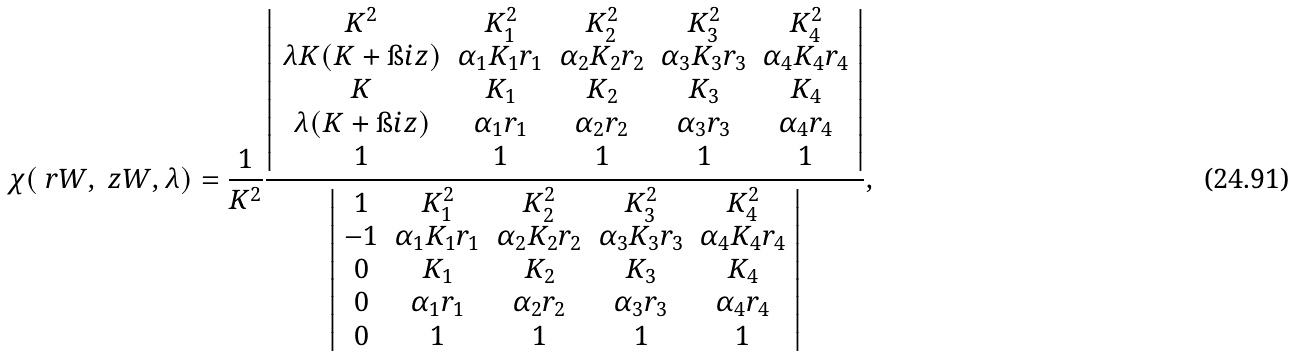<formula> <loc_0><loc_0><loc_500><loc_500>\chi ( \ r W , \ z W , \lambda ) = \frac { 1 } { K ^ { 2 } } \frac { \left | \begin{array} { c c c c c } K ^ { 2 } & K _ { 1 } ^ { 2 } & K _ { 2 } ^ { 2 } & K _ { 3 } ^ { 2 } & K _ { 4 } ^ { 2 } \\ \lambda K ( K + \i i z ) & \alpha _ { 1 } K _ { 1 } r _ { 1 } & \alpha _ { 2 } K _ { 2 } r _ { 2 } & \alpha _ { 3 } K _ { 3 } r _ { 3 } & \alpha _ { 4 } K _ { 4 } r _ { 4 } \\ K & K _ { 1 } & K _ { 2 } & K _ { 3 } & K _ { 4 } \\ \lambda ( K + \i i z ) & \alpha _ { 1 } r _ { 1 } & \alpha _ { 2 } r _ { 2 } & \alpha _ { 3 } r _ { 3 } & \alpha _ { 4 } r _ { 4 } \\ 1 & 1 & 1 & 1 & 1 \end{array} \right | } { \left | \begin{array} { c c c c c } 1 & K _ { 1 } ^ { 2 } & K _ { 2 } ^ { 2 } & K _ { 3 } ^ { 2 } & K _ { 4 } ^ { 2 } \\ - 1 & \alpha _ { 1 } K _ { 1 } r _ { 1 } & \alpha _ { 2 } K _ { 2 } r _ { 2 } & \alpha _ { 3 } K _ { 3 } r _ { 3 } & \alpha _ { 4 } K _ { 4 } r _ { 4 } \\ 0 & K _ { 1 } & K _ { 2 } & K _ { 3 } & K _ { 4 } \\ 0 & \alpha _ { 1 } r _ { 1 } & \alpha _ { 2 } r _ { 2 } & \alpha _ { 3 } r _ { 3 } & \alpha _ { 4 } r _ { 4 } \\ 0 & 1 & 1 & 1 & 1 \end{array} \right | } ,</formula> 